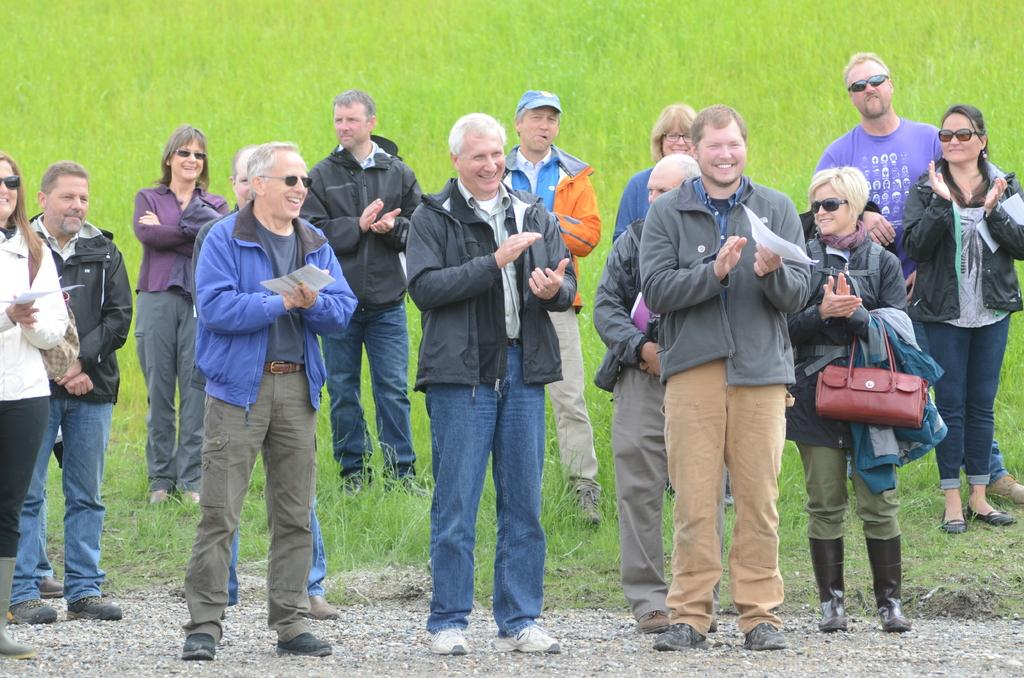What are the people in the image doing? The people in the image are standing, smiling, and clapping their hands. Are the people holding anything in their hands? Yes, some people are holding papers in their hands. What can be seen in the background of the image? There is grass visible in the background of the image. What type of cable can be seen connecting the brains of the people in the image? There is no cable connecting the brains of the people in the image, as there is no mention of any such device or connection in the provided facts. 